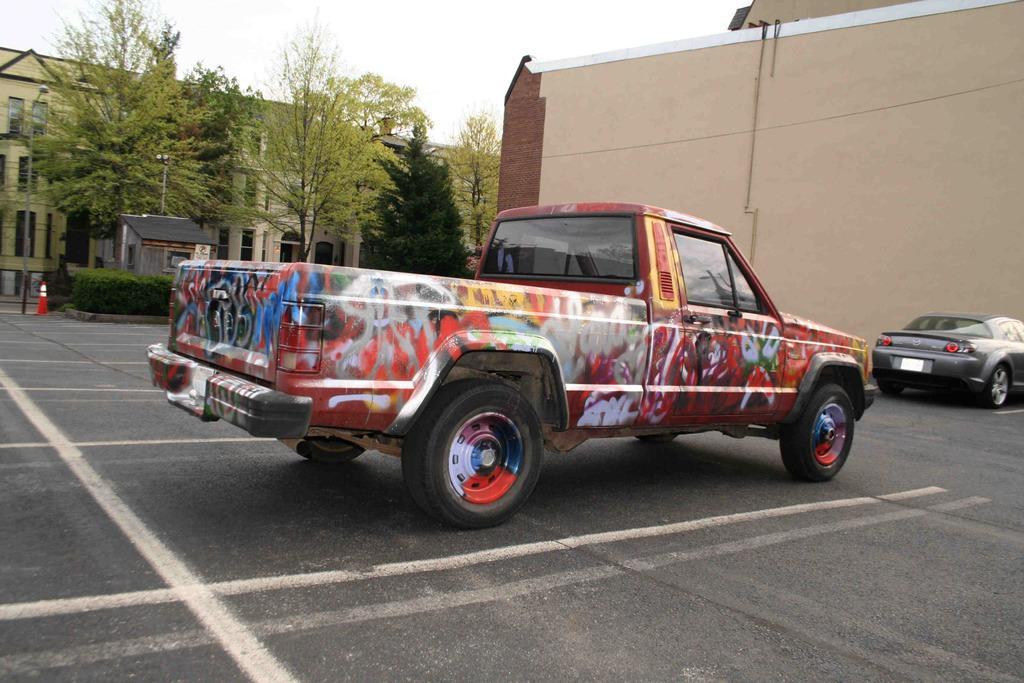Describe this image in one or two sentences. In this picture I can see there is a truck parked here and it is painted with different colors and on to right there is a car at the wall and in the backdrop there are plants and trees. 